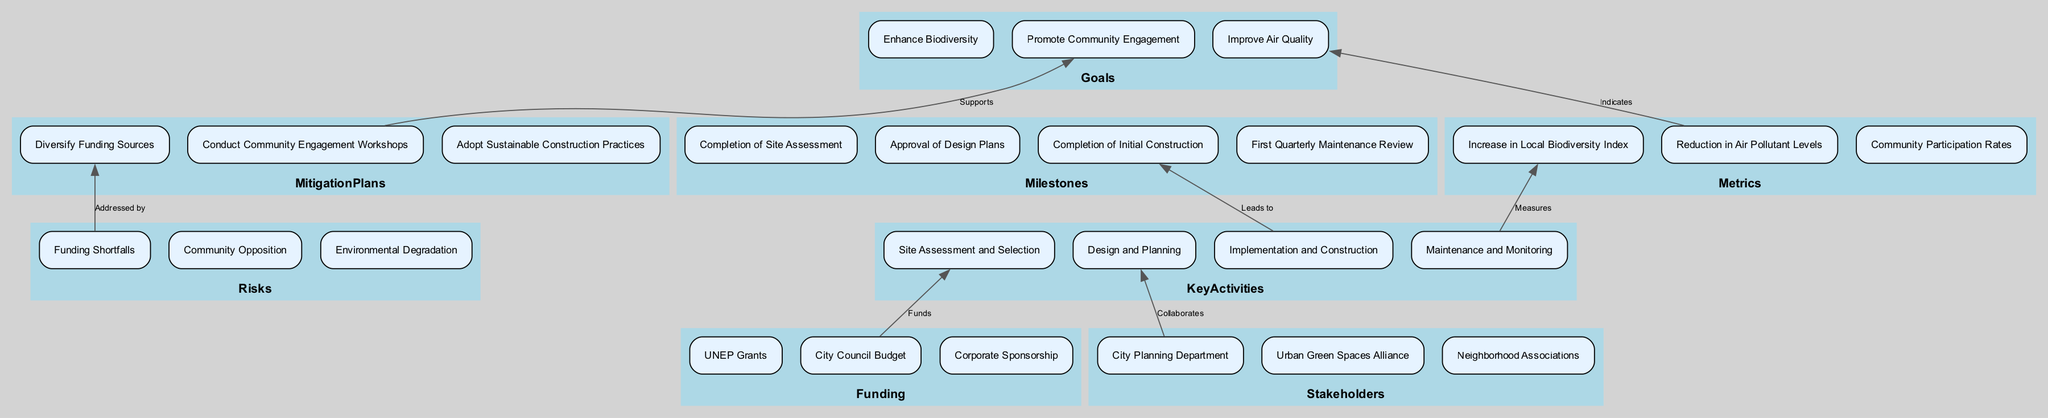What is the first key activity in the plan? The first key activity is represented in the diagram as "Site Assessment and Selection." It is located under the "Key Activities" cluster, positioned at the bottom of that section.
Answer: Site Assessment and Selection Which goal is indicated by the reduction in air pollutant levels? The diagram shows that the "Reduction in Air Pollutant Levels" metric indicates progress towards "Improve Air Quality," represented by an arrow connecting these nodes.
Answer: Improve Air Quality How many funding sources are listed in the diagram? There are three funding sources depicted in the "Funding" section: "UNEP Grants," "City Council Budget," and "Corporate Sponsorship." Counting these nodes gives a total of three sources.
Answer: 3 What is the last milestone listed in the plan? The last milestone shown in the diagram is "First Quarterly Maintenance Review," located at the bottom of the "Milestones" section, indicating a future review after initial construction.
Answer: First Quarterly Maintenance Review What risk is associated with funding shortfalls? The diagram illustrates that "Funding Shortfalls" is directly addressed by the mitigation plan "Diversify Funding Sources," which demonstrates a connection between these two nodes.
Answer: Diversify Funding Sources Which stakeholder collaborates on the design and planning activity? According to the diagram, the "Local Government," specifically the "City Planning Department," collaborates on the "Design and Planning" activity, as indicated by the edge connecting these nodes.
Answer: City Planning Department What activity leads to the completion of the initial construction? The diagram indicates that "Implementation and Construction," as a key activity, leads to the "Completion of Initial Construction," showing a direct flow between these two nodes.
Answer: Implementation and Construction Which activity measures the increase in local biodiversity index? The diagram specifies that "Maintenance and Monitoring" is the activity that measures the "Increase in Local Biodiversity Index" according to the connection depicted in the flowchart.
Answer: Maintenance and Monitoring 